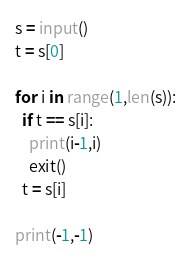Convert code to text. <code><loc_0><loc_0><loc_500><loc_500><_Python_>s = input()
t = s[0]

for i in range(1,len(s)):
  if t == s[i]:
    print(i-1,i)
    exit()
  t = s[i]
    
print(-1,-1)</code> 